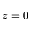<formula> <loc_0><loc_0><loc_500><loc_500>z = 0</formula> 